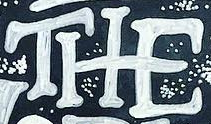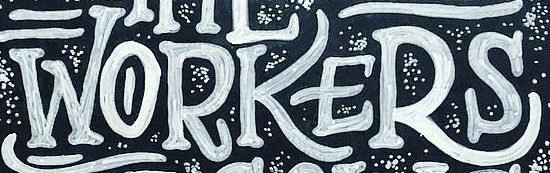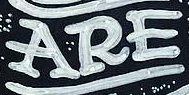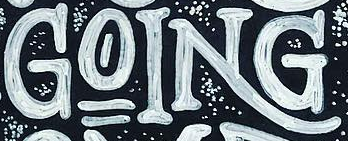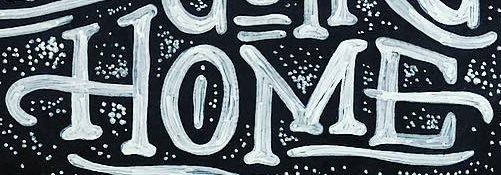What words can you see in these images in sequence, separated by a semicolon? THE; WORKERS; ARE; GOING; HOME 